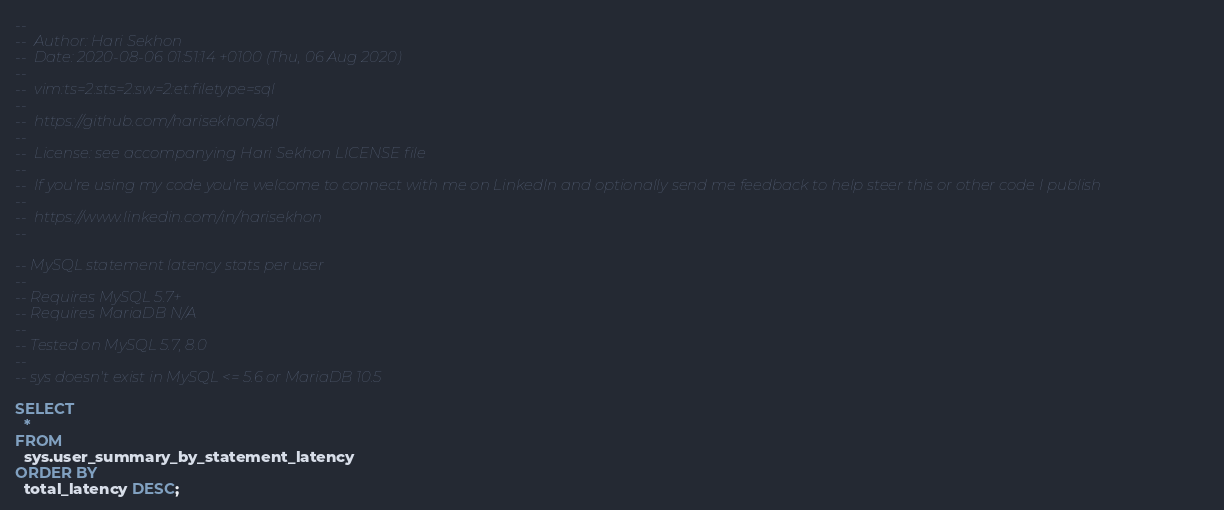Convert code to text. <code><loc_0><loc_0><loc_500><loc_500><_SQL_>--
--  Author: Hari Sekhon
--  Date: 2020-08-06 01:51:14 +0100 (Thu, 06 Aug 2020)
--
--  vim:ts=2:sts=2:sw=2:et:filetype=sql
--
--  https://github.com/harisekhon/sql
--
--  License: see accompanying Hari Sekhon LICENSE file
--
--  If you're using my code you're welcome to connect with me on LinkedIn and optionally send me feedback to help steer this or other code I publish
--
--  https://www.linkedin.com/in/harisekhon
--

-- MySQL statement latency stats per user
--
-- Requires MySQL 5.7+
-- Requires MariaDB N/A
--
-- Tested on MySQL 5.7, 8.0
--
-- sys doesn't exist in MySQL <= 5.6 or MariaDB 10.5

SELECT
  *
FROM
  sys.user_summary_by_statement_latency
ORDER BY
  total_latency DESC;
</code> 